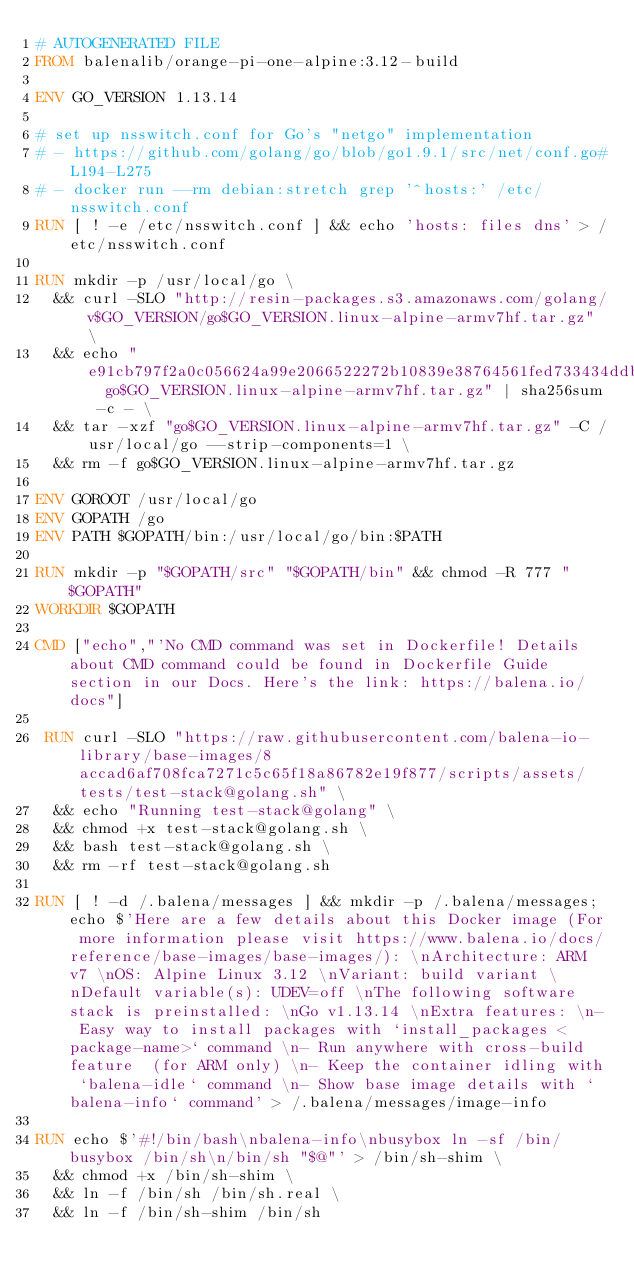<code> <loc_0><loc_0><loc_500><loc_500><_Dockerfile_># AUTOGENERATED FILE
FROM balenalib/orange-pi-one-alpine:3.12-build

ENV GO_VERSION 1.13.14

# set up nsswitch.conf for Go's "netgo" implementation
# - https://github.com/golang/go/blob/go1.9.1/src/net/conf.go#L194-L275
# - docker run --rm debian:stretch grep '^hosts:' /etc/nsswitch.conf
RUN [ ! -e /etc/nsswitch.conf ] && echo 'hosts: files dns' > /etc/nsswitch.conf

RUN mkdir -p /usr/local/go \
	&& curl -SLO "http://resin-packages.s3.amazonaws.com/golang/v$GO_VERSION/go$GO_VERSION.linux-alpine-armv7hf.tar.gz" \
	&& echo "e91cb797f2a0c056624a99e2066522272b10839e38764561fed733434ddb6882  go$GO_VERSION.linux-alpine-armv7hf.tar.gz" | sha256sum -c - \
	&& tar -xzf "go$GO_VERSION.linux-alpine-armv7hf.tar.gz" -C /usr/local/go --strip-components=1 \
	&& rm -f go$GO_VERSION.linux-alpine-armv7hf.tar.gz

ENV GOROOT /usr/local/go
ENV GOPATH /go
ENV PATH $GOPATH/bin:/usr/local/go/bin:$PATH

RUN mkdir -p "$GOPATH/src" "$GOPATH/bin" && chmod -R 777 "$GOPATH"
WORKDIR $GOPATH

CMD ["echo","'No CMD command was set in Dockerfile! Details about CMD command could be found in Dockerfile Guide section in our Docs. Here's the link: https://balena.io/docs"]

 RUN curl -SLO "https://raw.githubusercontent.com/balena-io-library/base-images/8accad6af708fca7271c5c65f18a86782e19f877/scripts/assets/tests/test-stack@golang.sh" \
  && echo "Running test-stack@golang" \
  && chmod +x test-stack@golang.sh \
  && bash test-stack@golang.sh \
  && rm -rf test-stack@golang.sh 

RUN [ ! -d /.balena/messages ] && mkdir -p /.balena/messages; echo $'Here are a few details about this Docker image (For more information please visit https://www.balena.io/docs/reference/base-images/base-images/): \nArchitecture: ARM v7 \nOS: Alpine Linux 3.12 \nVariant: build variant \nDefault variable(s): UDEV=off \nThe following software stack is preinstalled: \nGo v1.13.14 \nExtra features: \n- Easy way to install packages with `install_packages <package-name>` command \n- Run anywhere with cross-build feature  (for ARM only) \n- Keep the container idling with `balena-idle` command \n- Show base image details with `balena-info` command' > /.balena/messages/image-info

RUN echo $'#!/bin/bash\nbalena-info\nbusybox ln -sf /bin/busybox /bin/sh\n/bin/sh "$@"' > /bin/sh-shim \
	&& chmod +x /bin/sh-shim \
	&& ln -f /bin/sh /bin/sh.real \
	&& ln -f /bin/sh-shim /bin/sh</code> 